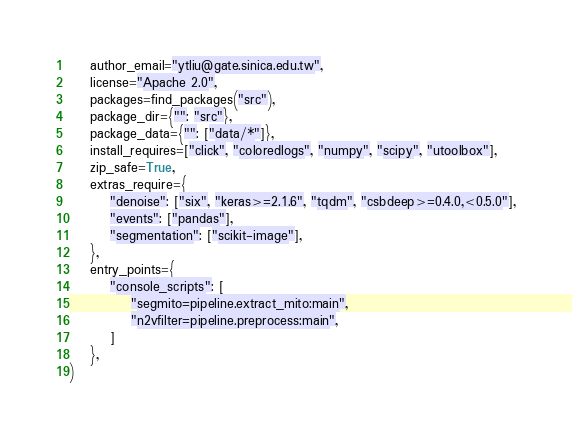Convert code to text. <code><loc_0><loc_0><loc_500><loc_500><_Python_>    author_email="ytliu@gate.sinica.edu.tw",
    license="Apache 2.0",
    packages=find_packages("src"),
    package_dir={"": "src"},
    package_data={"": ["data/*"]},
    install_requires=["click", "coloredlogs", "numpy", "scipy", "utoolbox"],
    zip_safe=True,
    extras_require={
        "denoise": ["six", "keras>=2.1.6", "tqdm", "csbdeep>=0.4.0,<0.5.0"],
        "events": ["pandas"],
        "segmentation": ["scikit-image"],
    },
    entry_points={
        "console_scripts": [
            "segmito=pipeline.extract_mito:main",
            "n2vfilter=pipeline.preprocess:main",
        ]
    },
)
</code> 